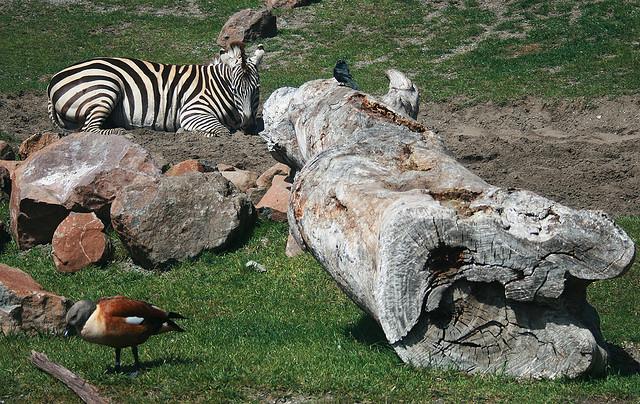Is the wood petrified?
Be succinct. Yes. How many different animals do you see?
Quick response, please. 3. Is the zebra asleep?
Write a very short answer. Yes. 